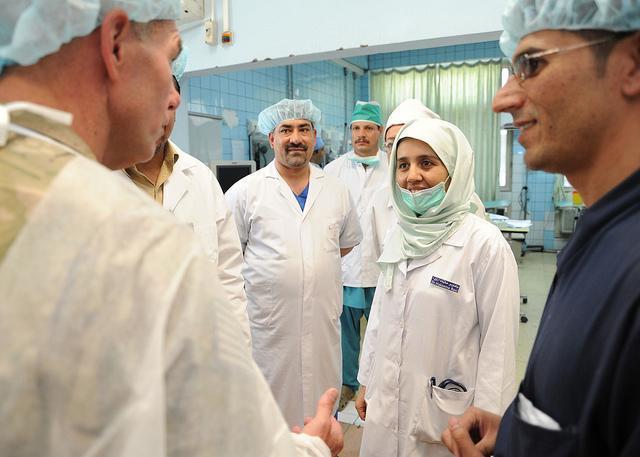How many men are there?
Give a very brief answer. 5. How many people can you see?
Give a very brief answer. 7. 